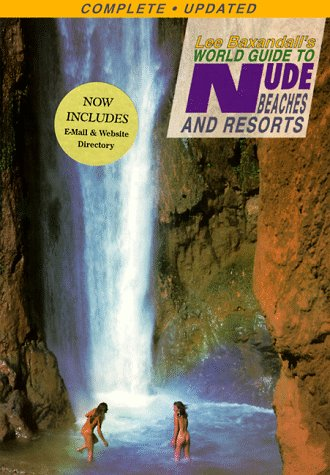What type of locations does this guide discuss? This guide discusses various nude beaches and resorts, providing information about their locations, amenities, and visitor experiences. 